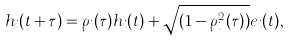Convert formula to latex. <formula><loc_0><loc_0><loc_500><loc_500>h _ { i } ( t + \tau ) = \rho _ { i } ( \tau ) h _ { i } ( t ) + \sqrt { ( 1 - \rho _ { i } ^ { 2 } ( \tau ) ) } e _ { i } ( t ) ,</formula> 